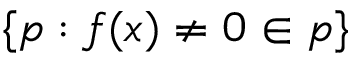Convert formula to latex. <formula><loc_0><loc_0><loc_500><loc_500>\{ p \colon f ( x ) \neq 0 \in p \}</formula> 